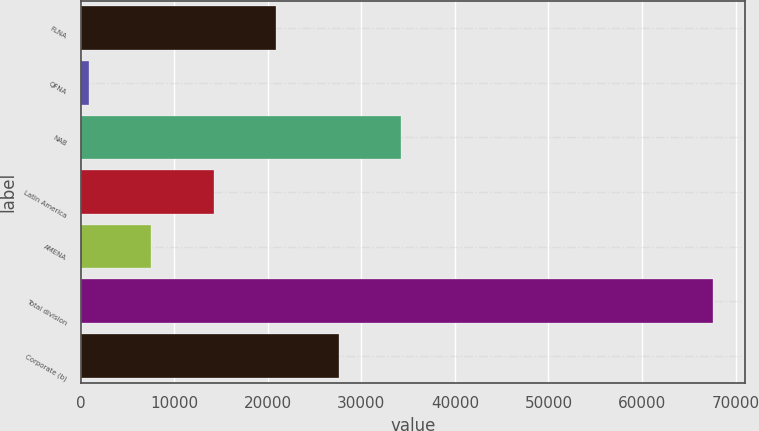<chart> <loc_0><loc_0><loc_500><loc_500><bar_chart><fcel>FLNA<fcel>QFNA<fcel>NAB<fcel>Latin America<fcel>AMENA<fcel>Total division<fcel>Corporate (b)<nl><fcel>20896.8<fcel>870<fcel>34248<fcel>14221.2<fcel>7545.6<fcel>67626<fcel>27572.4<nl></chart> 